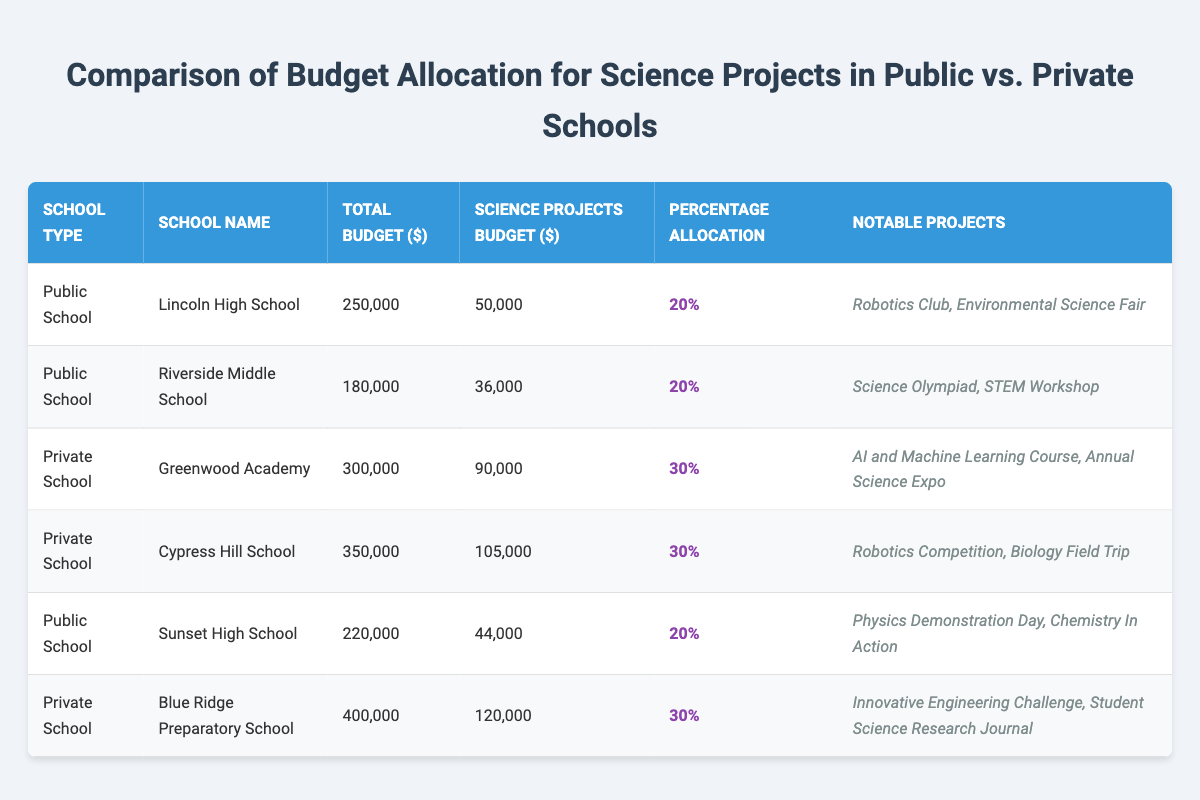What is the science projects budget for Lincoln High School? According to the table, Lincoln High School has a science projects budget of $50,000.
Answer: 50,000 What is the total budget of Blue Ridge Preparatory School? The table indicates that Blue Ridge Preparatory School has a total budget of $400,000.
Answer: 400,000 How much percentage of the total budget is allocated for science projects in public schools? The percentage allocation for science projects in public schools is 20%, as noted in the entries for Lincoln High School, Riverside Middle School, and Sunset High School.
Answer: 20% Is the total budget for Cypress Hill School higher than that of Greenwood Academy? Yes, Cypress Hill School's total budget is $350,000, which is higher than Greenwood Academy's total budget of $300,000.
Answer: Yes Which school allocates the highest amount for science projects? Blue Ridge Preparatory School allocates the highest amount for science projects, which is $120,000. This is determined by comparing the science projects budget across all schools listed.
Answer: 120,000 What is the average percentage allocation for science projects in private schools? The percentage allocations for private schools are 30% for Greenwood Academy, 30% for Cypress Hill School, and 30% for Blue Ridge Preparatory School. Adding these gives a total of 90%, divided by 3 (the number of private schools), resulting in an average of 30%.
Answer: 30% How much more is allocated for science projects in private schools compared to public schools? The total science projects budget for private schools is $90,000 + $105,000 + $120,000 = $315,000, while for public schools, it is $50,000 + $36,000 + $44,000 = $130,000. The difference is $315,000 - $130,000 = $185,000.
Answer: 185,000 Is the notable project for Lincoln High School related to robotics? Yes, one of the notable projects for Lincoln High School is the Robotics Club, indicating a focus on robotics.
Answer: Yes What notable projects are associated with Sunset High School? Sunset High School's notable projects include Physics Demonstration Day and Chemistry In Action, as listed in the table.
Answer: Physics Demonstration Day, Chemistry In Action 